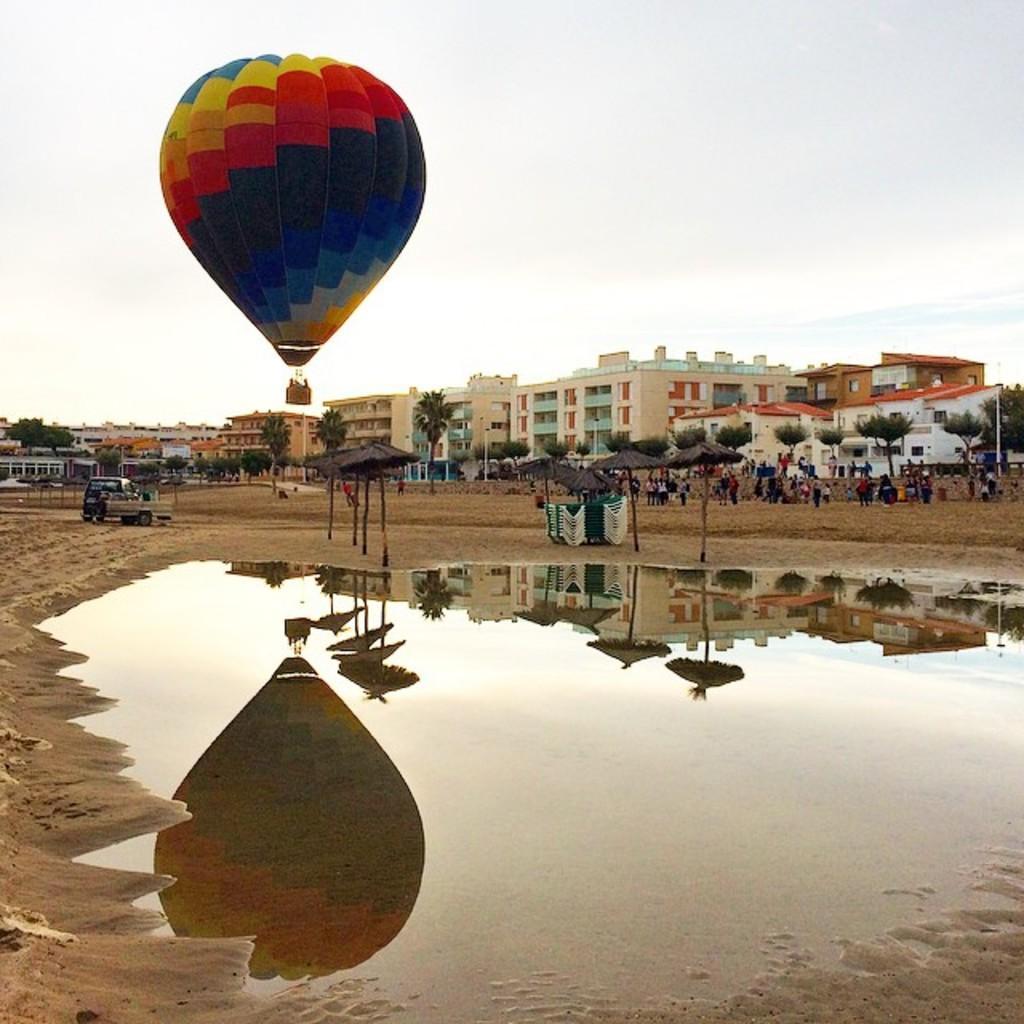Could you give a brief overview of what you see in this image? In the center of the image we can see water and sand. And we can see the reflection of some objects on the water. In the background, we can see the sky, buildings, trees, thatched umbrellas, one vehicle, few people are standing and a few other objects. 